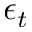<formula> <loc_0><loc_0><loc_500><loc_500>\epsilon _ { t }</formula> 